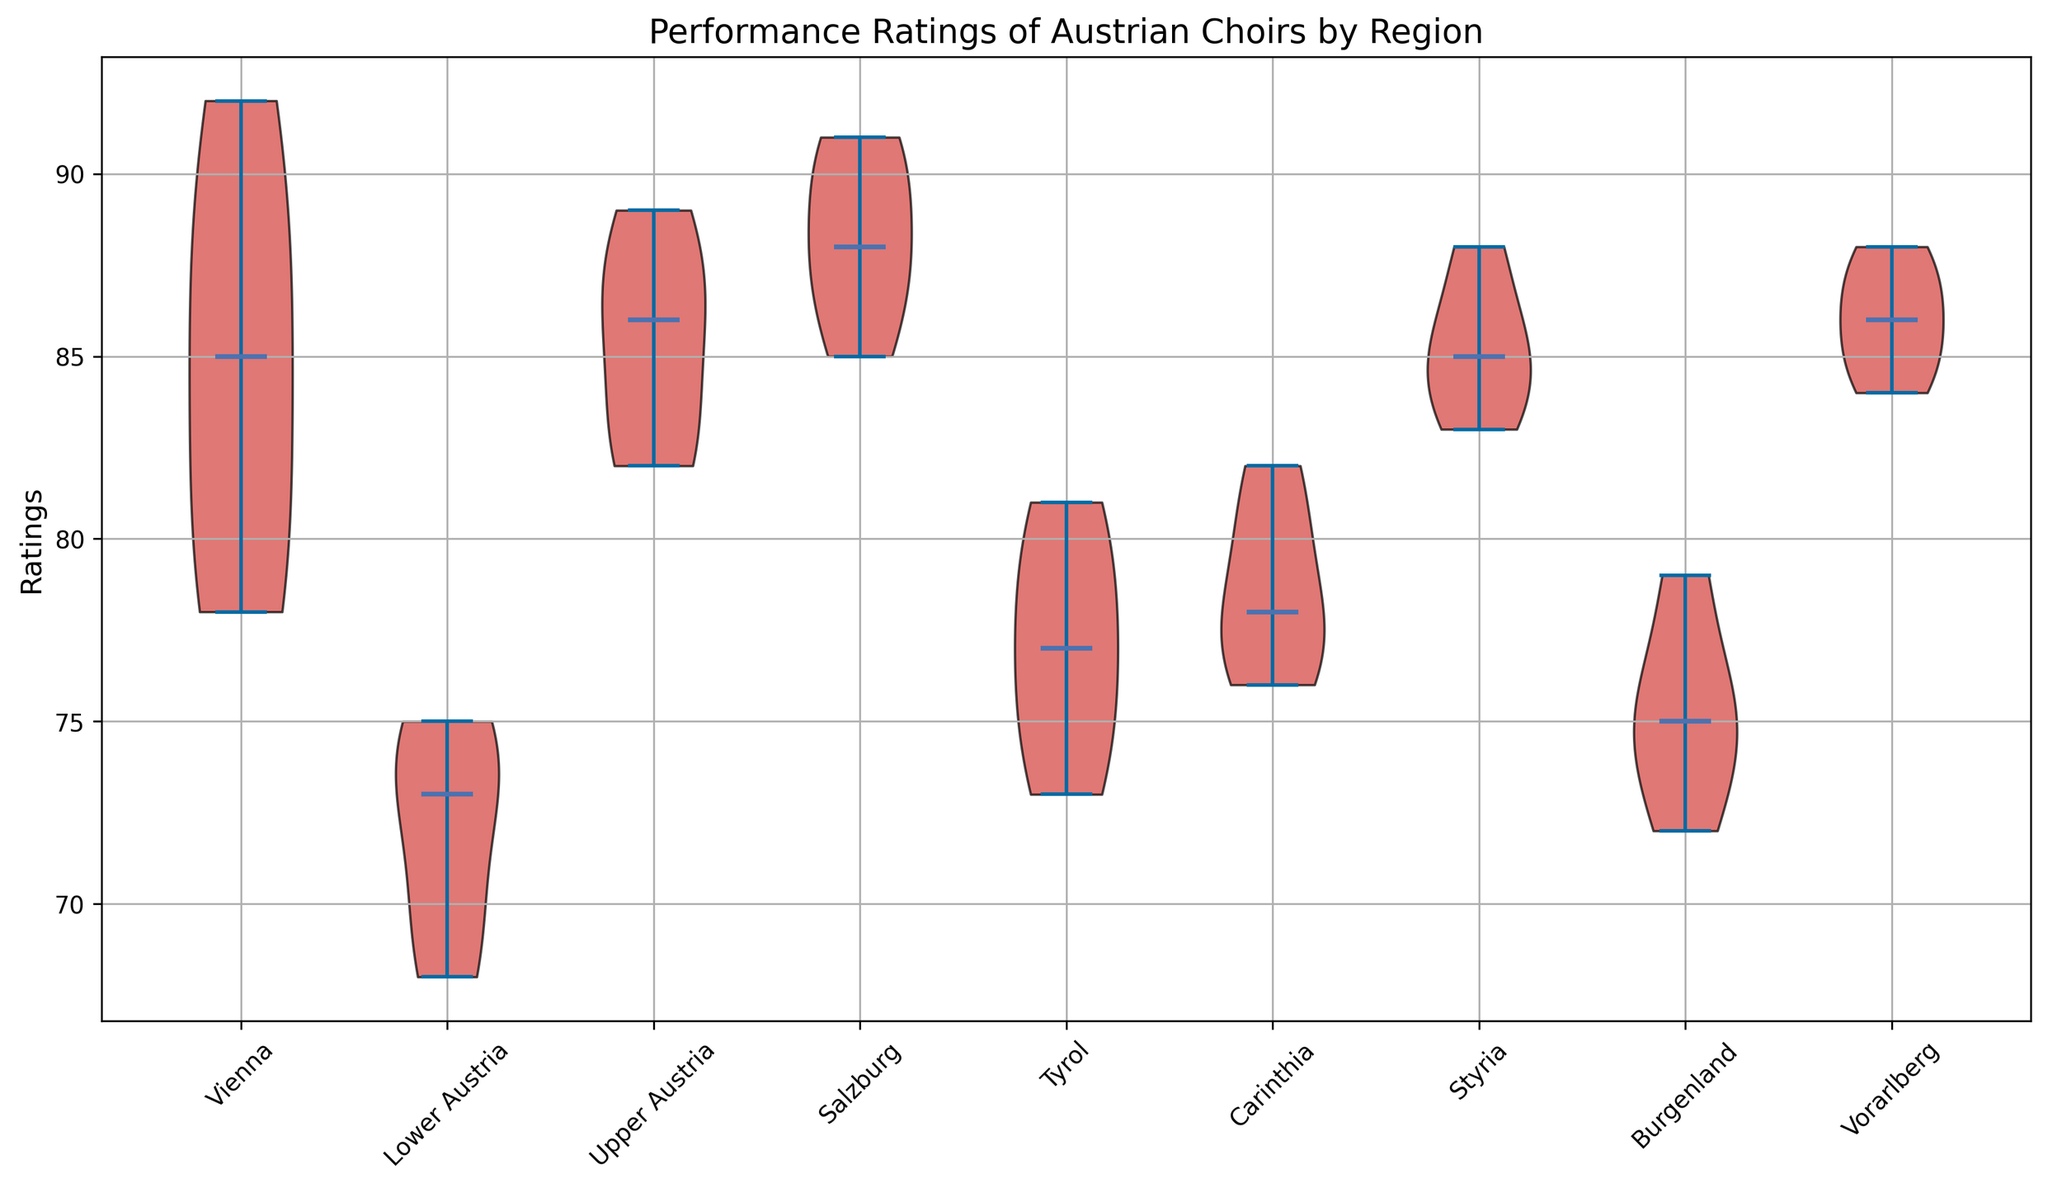Which region has the highest median performance rating? By looking at the box plot's median lines, the region with the highest median performance rating can be identified by its central line.
Answer: Salzburg Which region exhibits the smallest range in performance ratings? The region with the smallest range in performance ratings will have the shortest violins.
Answer: Carinthia What is the median performance rating for choirs in Vienna? The median can be identified by the horizontal line within the violin for Vienna.
Answer: 85 How do the performance ratings in Upper Austria compare to those in Lower Austria? Compare the median lines as well as the spread (height) of the violins for Upper Austria and Lower Austria. Upper Austria has a higher median and a wider spread.
Answer: Upper Austria has higher ratings Which regions have medians above 85? By visually comparing the medians of each region to the value of 85, identify those that are above 85.
Answer: Vienna, Upper Austria, Salzburg, Styria, Vorarlberg What is the performance rating spread for choirs in Salzburg? Look for the highest and lowest point of the violin plot for Salzburg to determine the range.
Answer: 87 to 91 Assess the variation in performance ratings for choirs in Tyrol. The variation can be understood by observing the spread and shape of the violin plot. Tyrol has a moderate spread, indicating moderate variation.
Answer: Moderate variation Comparing the regions of Burgenland and Carinthia, which has a wider spread of ratings? Look at the lengths of the violins for Burgenland and Carinthia to determine which has a wider spread.
Answer: Burgenland Do any regions have outliers in their performance ratings? Typically, outliers are indicated by distinct points outside the main body of the violin plot. However, detailed inspection is needed for each region in this visualization.
Answer: No visible outliers 